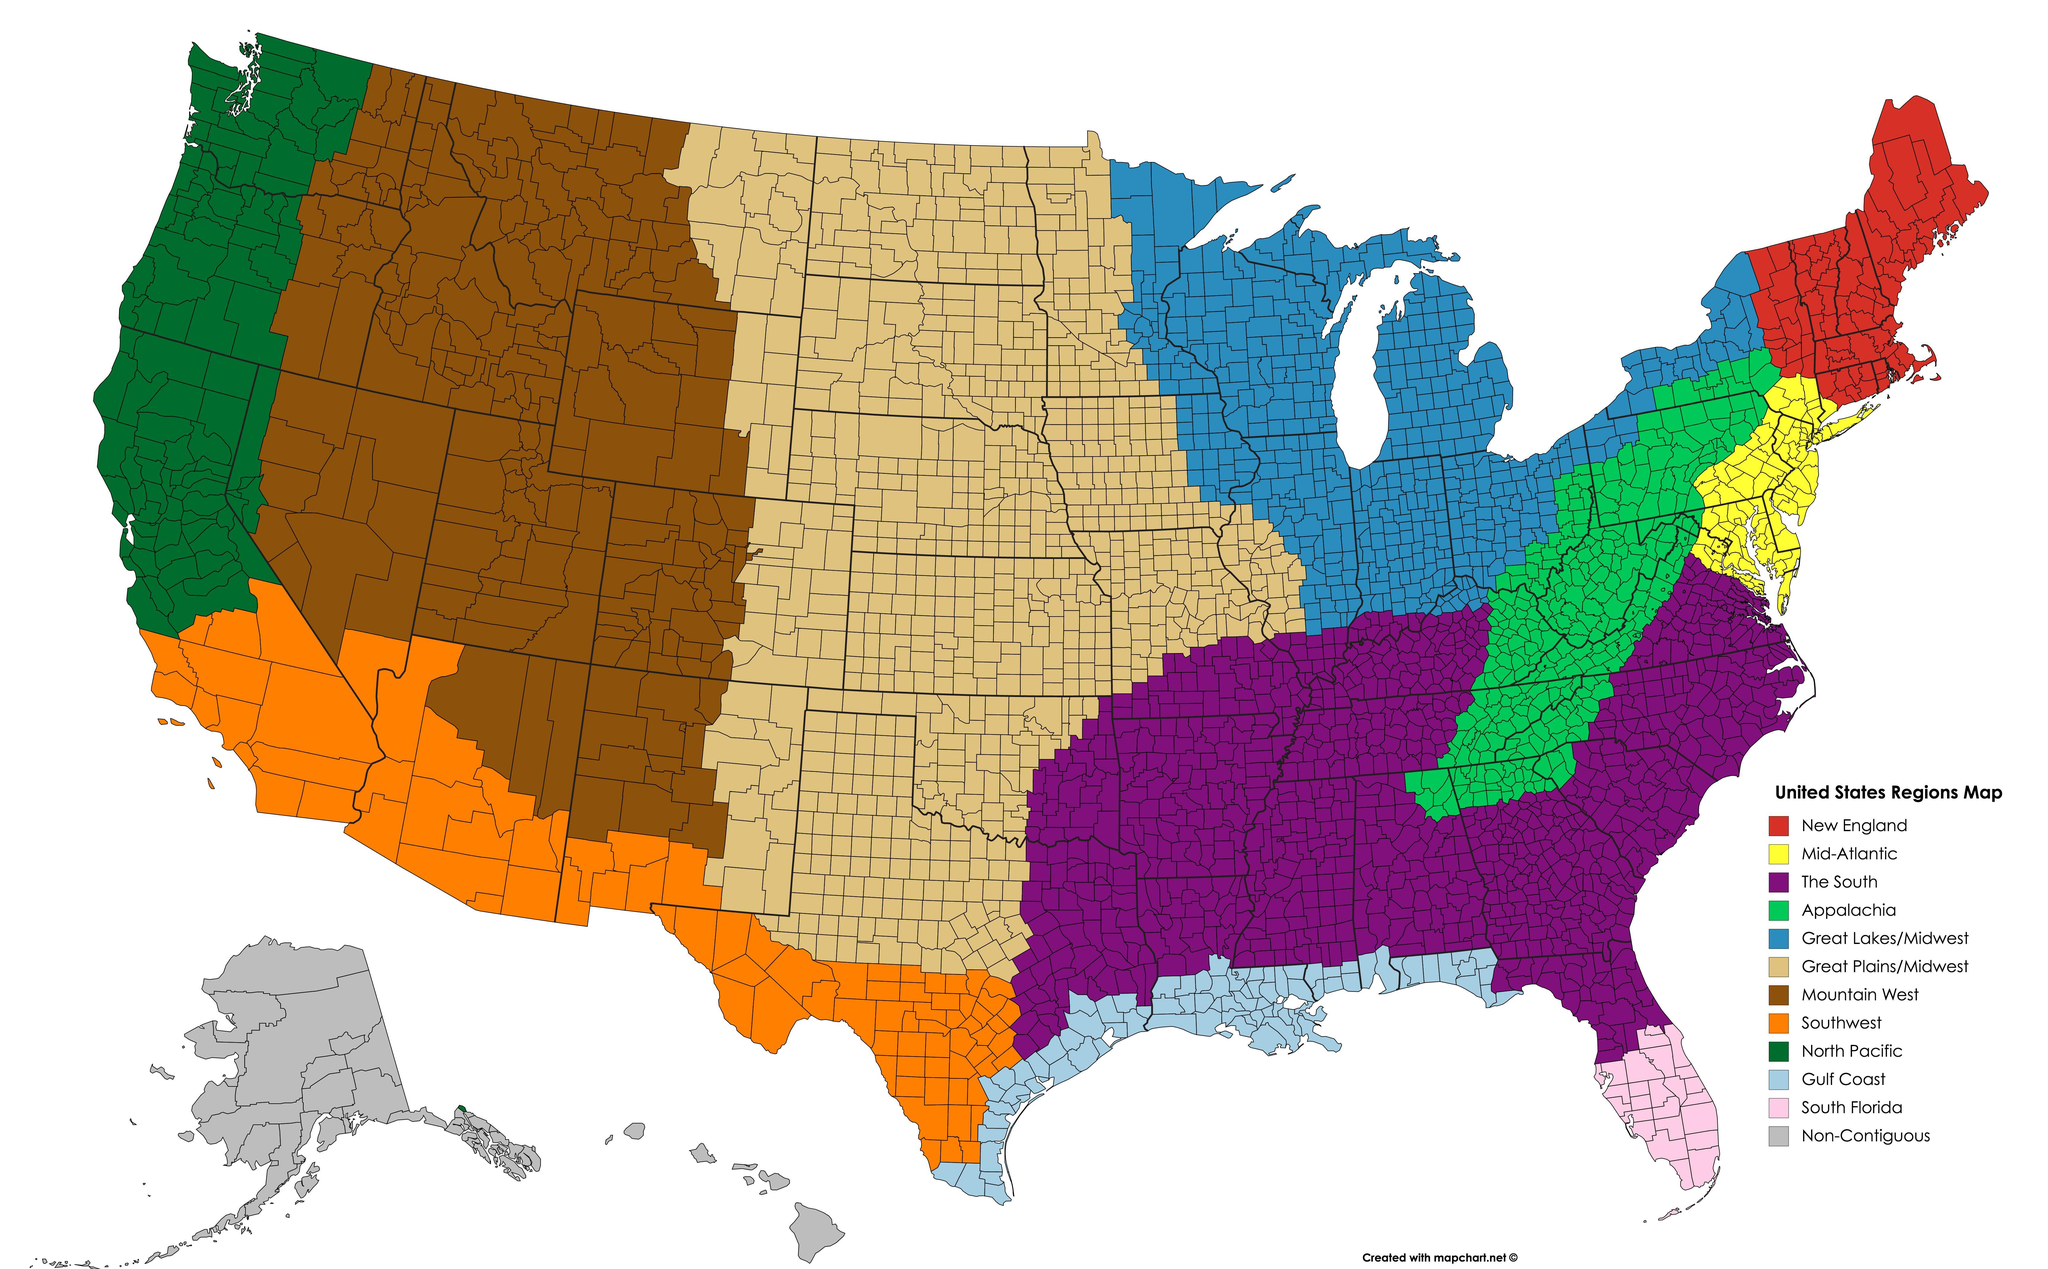What is color of the region New England in the map , grey, yellow or red?
Answer the question with a short phrase. red Which region lies to the South of the region Mountain West? Southwest Which region falls to the west of Mountain West ? North Pacific How many regions are listed in the map? 12 Which region in the US does the Purple color refer to in the map? The South Which region falls to the east of the Mountain West ? Great Plains/ Midwest What is color of the region Mid- Atlantic, yellow, green or purple ? yellow 